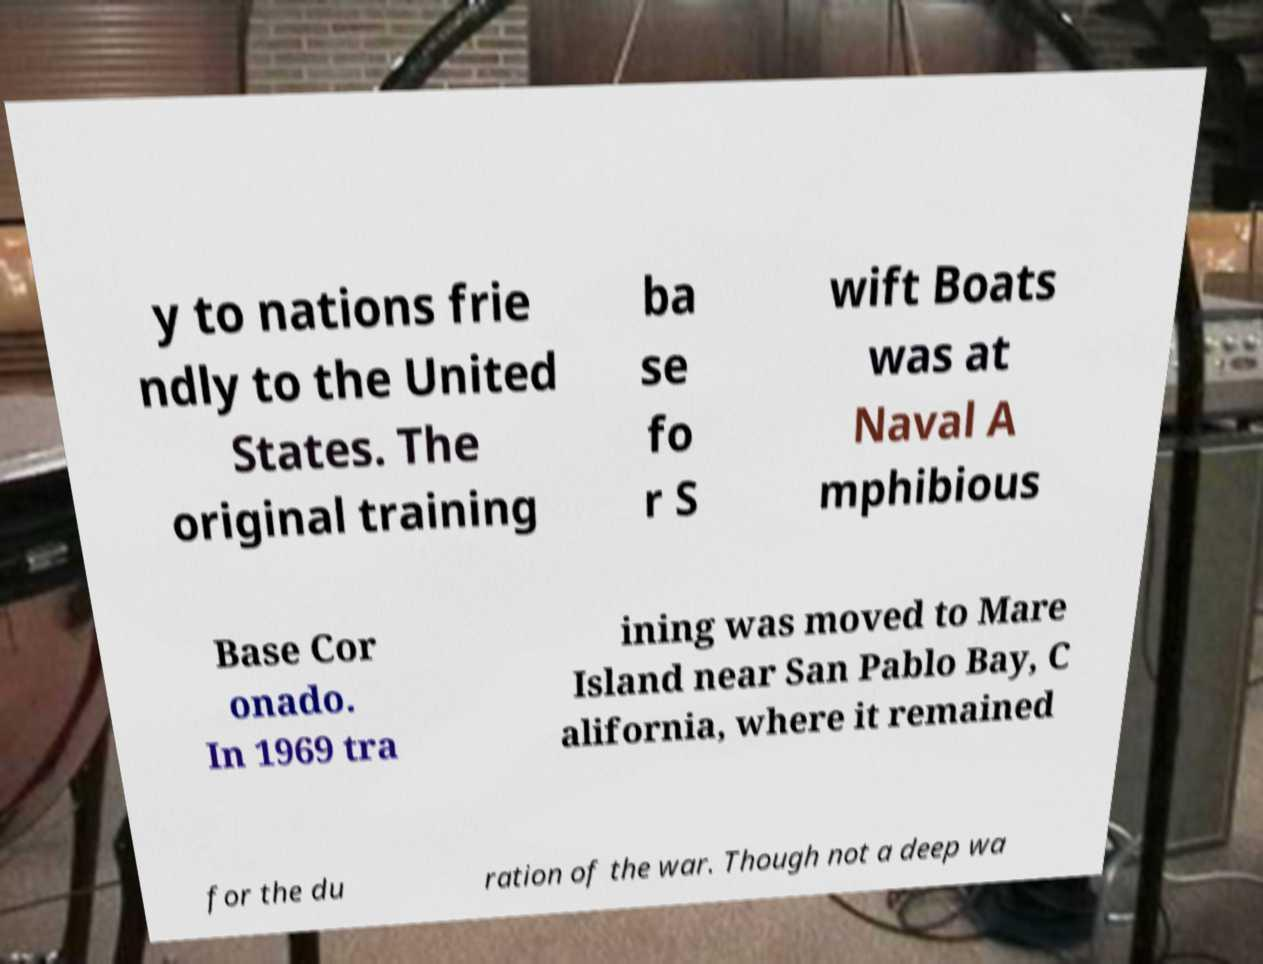Could you extract and type out the text from this image? y to nations frie ndly to the United States. The original training ba se fo r S wift Boats was at Naval A mphibious Base Cor onado. In 1969 tra ining was moved to Mare Island near San Pablo Bay, C alifornia, where it remained for the du ration of the war. Though not a deep wa 